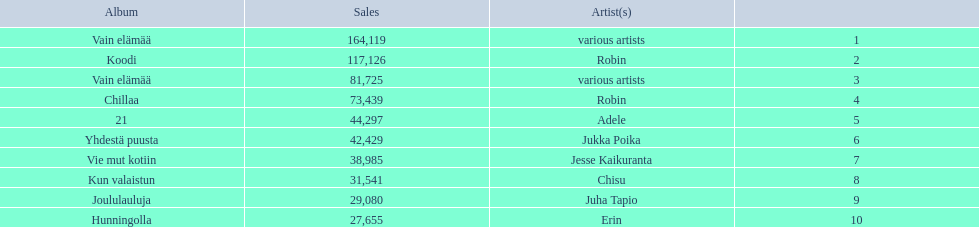Can you give me this table in json format? {'header': ['Album', 'Sales', 'Artist(s)', ''], 'rows': [['Vain elämää', '164,119', 'various artists', '1'], ['Koodi', '117,126', 'Robin', '2'], ['Vain elämää', '81,725', 'various artists', '3'], ['Chillaa', '73,439', 'Robin', '4'], ['21', '44,297', 'Adele', '5'], ['Yhdestä puusta', '42,429', 'Jukka Poika', '6'], ['Vie mut kotiin', '38,985', 'Jesse Kaikuranta', '7'], ['Kun valaistun', '31,541', 'Chisu', '8'], ['Joululauluja', '29,080', 'Juha Tapio', '9'], ['Hunningolla', '27,655', 'Erin', '10']]} Which albums had number-one albums in finland in 2012? 1, Vain elämää, Koodi, Vain elämää, Chillaa, 21, Yhdestä puusta, Vie mut kotiin, Kun valaistun, Joululauluja, Hunningolla. Of those albums, which were recorded by only one artist? Koodi, Chillaa, 21, Yhdestä puusta, Vie mut kotiin, Kun valaistun, Joululauluja, Hunningolla. Which albums made between 30,000 and 45,000 in sales? 21, Yhdestä puusta, Vie mut kotiin, Kun valaistun. Of those albums which had the highest sales? 21. Who was the artist for that album? Adele. 